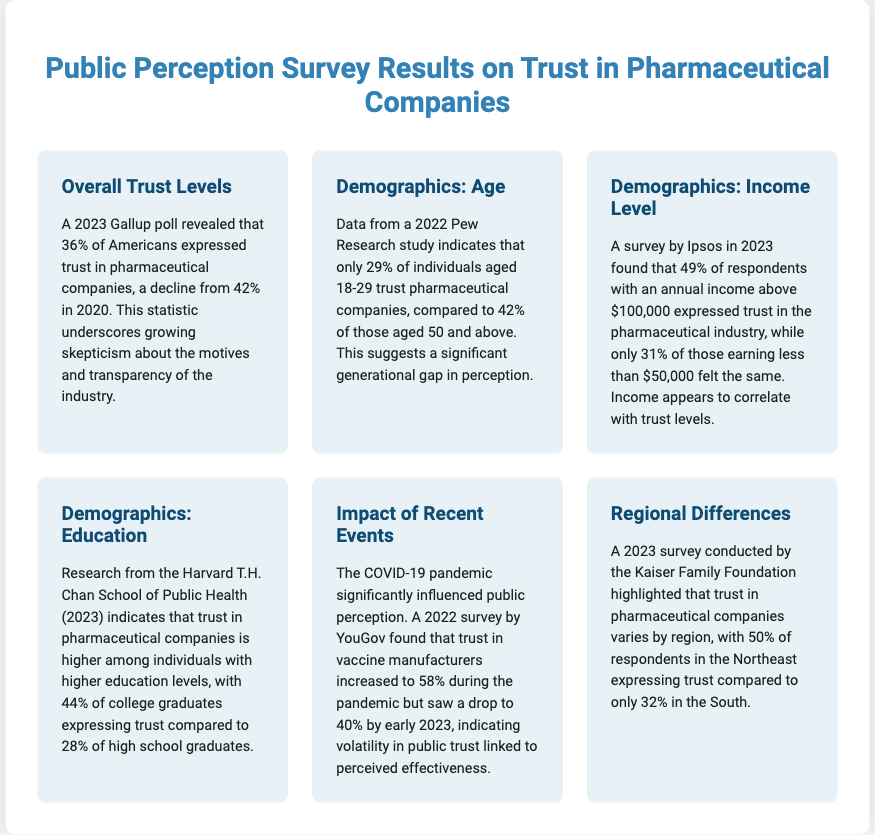what percentage of Americans trust pharmaceutical companies as of 2023? The document states that 36% of Americans expressed trust in pharmaceutical companies according to a 2023 Gallup poll.
Answer: 36% what was the trust percentage in pharmaceutical companies in 2020? The document mentions that 42% of Americans trusted pharmaceutical companies in 2020.
Answer: 42% which age group shows the highest level of trust in pharmaceutical companies? The document indicates that 42% of those aged 50 and above trust pharmaceutical companies, which is higher than younger age groups.
Answer: 50 and above what is the trust percentage among individuals earning less than $50,000 annually? According to the Ipsos survey in 2023, only 31% of respondents earning less than $50,000 expressed trust in pharmaceutical companies.
Answer: 31% how did trust in vaccine manufacturers change during the COVID-19 pandemic? The document highlights that trust increased to 58% during the pandemic but dropped to 40% by early 2023.
Answer: Increased to 58%, dropped to 40% which region has the highest reported trust in pharmaceutical companies? The document states that the Northeast has 50% of respondents expressing trust, which is higher than other regions like the South.
Answer: Northeast what demographic shows increased trust levels correlating with education? The research from Harvard indicates that college graduates have higher trust levels compared to high school graduates.
Answer: College graduates what is the trust percentage among college graduates according to the document? The document states that 44% of college graduates express trust in pharmaceutical companies.
Answer: 44% what was the trust level in vaccine manufacturers in early 2023? The document notes that trust in vaccine manufacturers dropped to 40% by early 2023.
Answer: 40% 